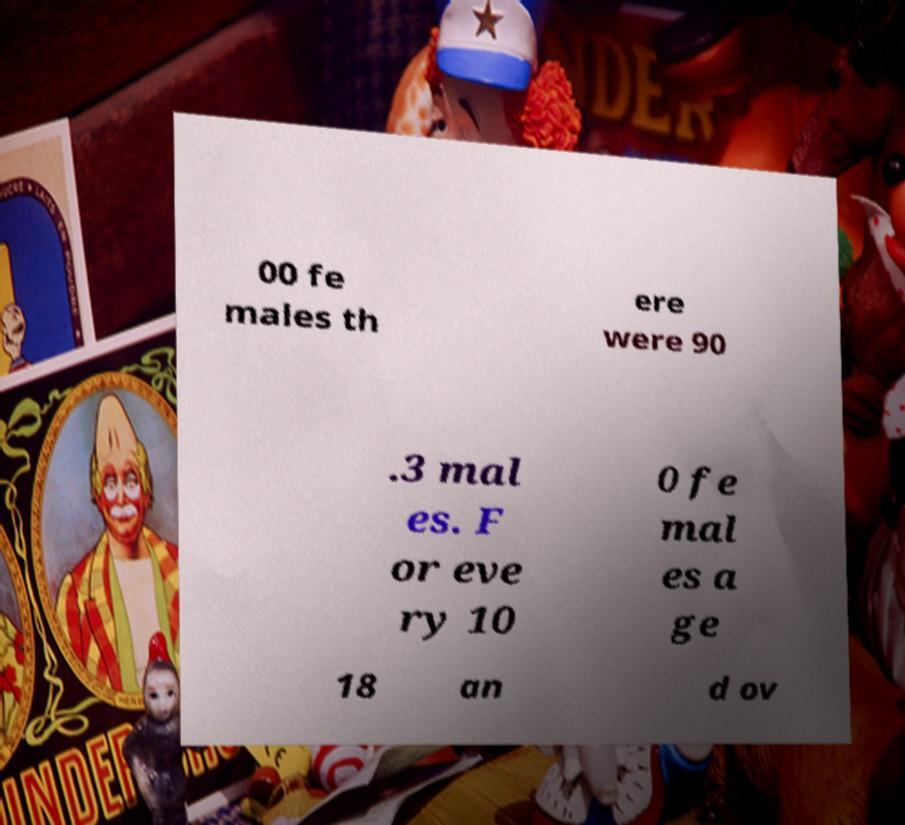I need the written content from this picture converted into text. Can you do that? 00 fe males th ere were 90 .3 mal es. F or eve ry 10 0 fe mal es a ge 18 an d ov 